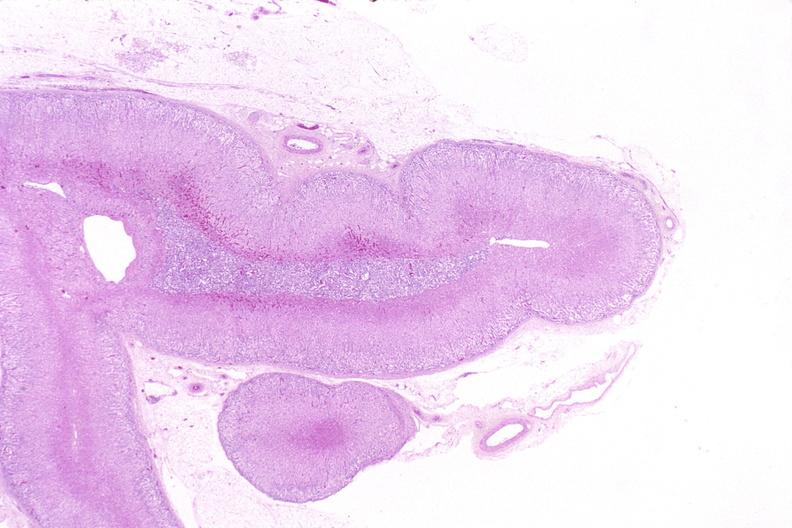s intraductal papillomatosis present?
Answer the question using a single word or phrase. No 